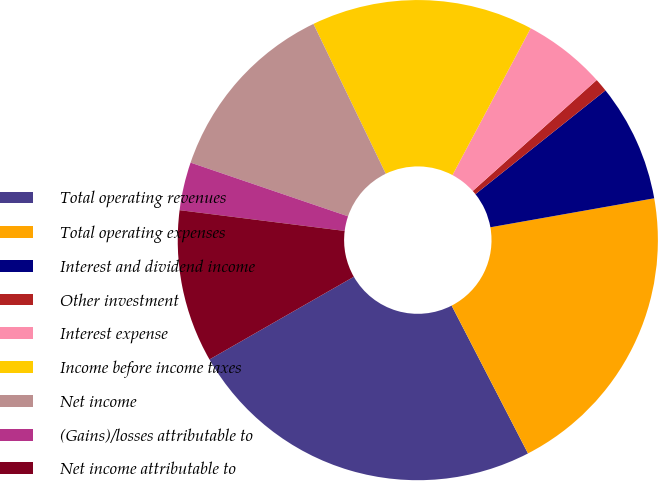Convert chart to OTSL. <chart><loc_0><loc_0><loc_500><loc_500><pie_chart><fcel>Total operating revenues<fcel>Total operating expenses<fcel>Interest and dividend income<fcel>Other investment<fcel>Interest expense<fcel>Income before income taxes<fcel>Net income<fcel>(Gains)/losses attributable to<fcel>Net income attributable to<nl><fcel>24.31%<fcel>20.2%<fcel>7.93%<fcel>0.9%<fcel>5.59%<fcel>14.95%<fcel>12.61%<fcel>3.24%<fcel>10.27%<nl></chart> 